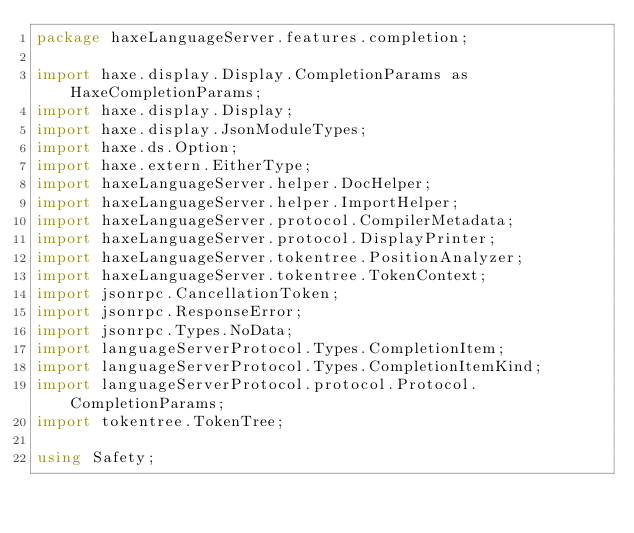Convert code to text. <code><loc_0><loc_0><loc_500><loc_500><_Haxe_>package haxeLanguageServer.features.completion;

import haxe.display.Display.CompletionParams as HaxeCompletionParams;
import haxe.display.Display;
import haxe.display.JsonModuleTypes;
import haxe.ds.Option;
import haxe.extern.EitherType;
import haxeLanguageServer.helper.DocHelper;
import haxeLanguageServer.helper.ImportHelper;
import haxeLanguageServer.protocol.CompilerMetadata;
import haxeLanguageServer.protocol.DisplayPrinter;
import haxeLanguageServer.tokentree.PositionAnalyzer;
import haxeLanguageServer.tokentree.TokenContext;
import jsonrpc.CancellationToken;
import jsonrpc.ResponseError;
import jsonrpc.Types.NoData;
import languageServerProtocol.Types.CompletionItem;
import languageServerProtocol.Types.CompletionItemKind;
import languageServerProtocol.protocol.Protocol.CompletionParams;
import tokentree.TokenTree;

using Safety;</code> 